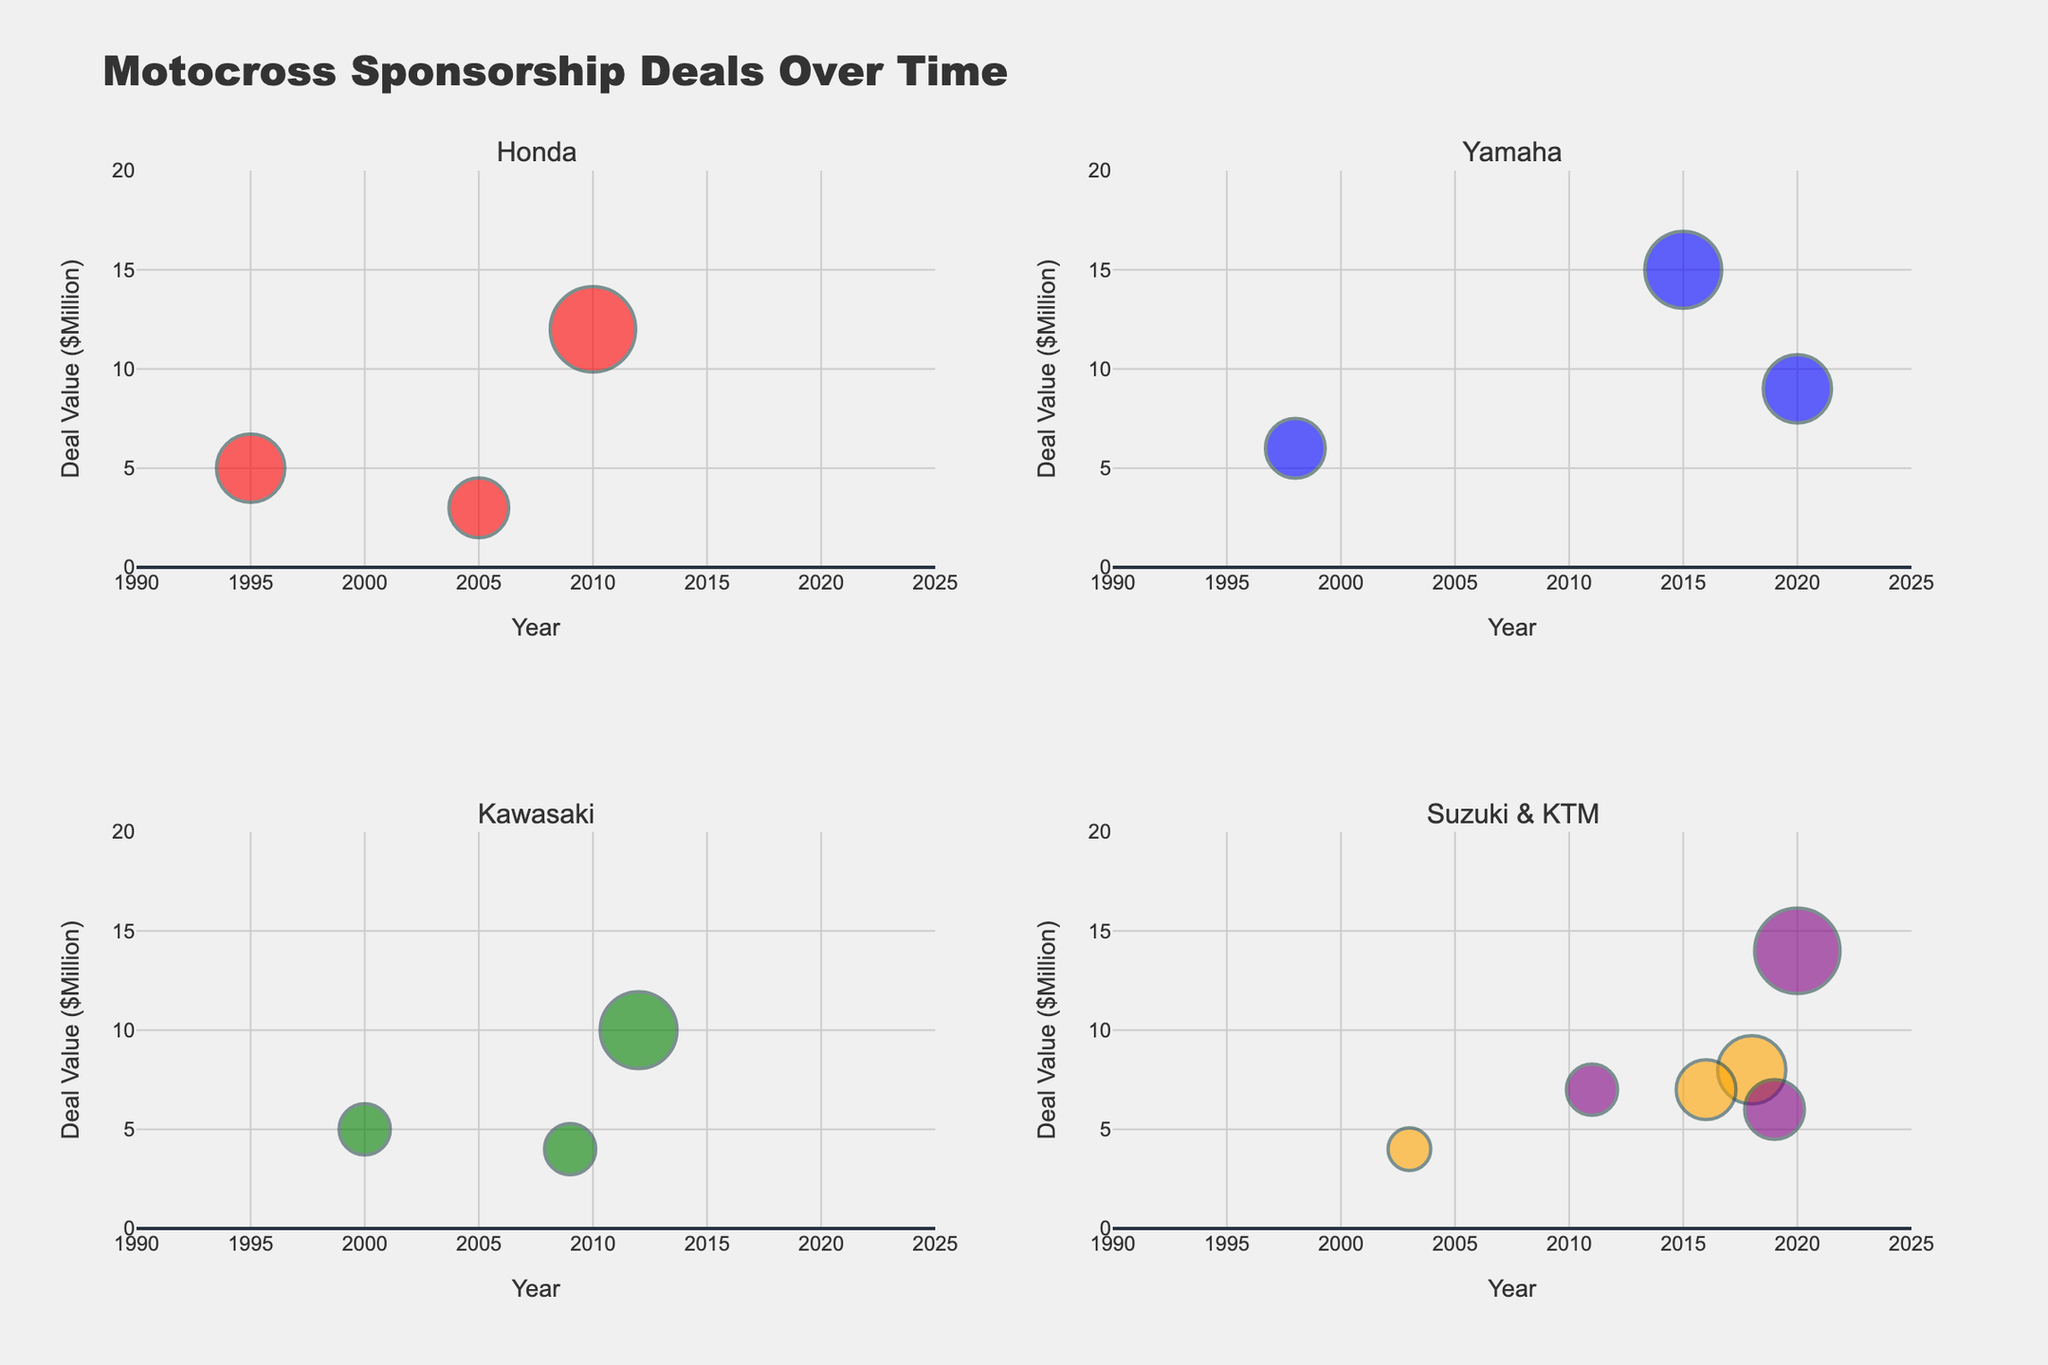What is the title of the plot? The title is found at the top of the plot, which provides an overview of what the visual represents.
Answer: "Motocross Sponsorship Deals Over Time" How many racing teams are mentioned in the plot? You can count the unique labels in each subplot to determine the number of racing teams.
Answer: 5 Which team had the highest deal value in 2020? Check the values for each team in the year 2020 and identify the highest. Team KTM has a deal with Red Bull valued at $14 million.
Answer: Team KTM What is the size of the markers in the subplots relative to? The marker size is determined by the Brand Popularity score, where higher scores mean larger markers.
Answer: Brand Popularity Score Which brand has the highest popularity score? Compare the popularity scores mentioned in each bubble and find the highest one. Both Red Bull deals (2010 and 2020) have a popularity score of 10.
Answer: Red Bull How many sponsorship deals did Team Honda secure over the years? Count the number of data points specific to Team Honda in its subplot.
Answer: 3 What is the average deal value for Team Suzuki's sponsorships? Add the deal values for Team Suzuki and divide by the number of deals: (4 + 8 + 7) / 3.
Answer: $6.33 million Which racing team has the most number of deals with energy drink brands? Check for energy drink brands in each team's subplot and count them. Team Yamaha has the most: Monster Energy and Alpinestars (brand under Monster Energy).
Answer: Team Yamaha Which year features the highest number of sponsorship deals across all teams? Count the number of deals in each year and identify the year with the highest count. 2020 has deals from Team KTM and Team Yamaha.
Answer: 2020 What is the trend of sponsorship deals for Team Kawasaki between 2000 and 2012? Observe the values for Team Kawasaki in the years 2000, 2009, and 2012 to identify an increasing or decreasing trend in deal value. It shows an increasing trend from $5M to $4M to $10M.
Answer: Increasing 